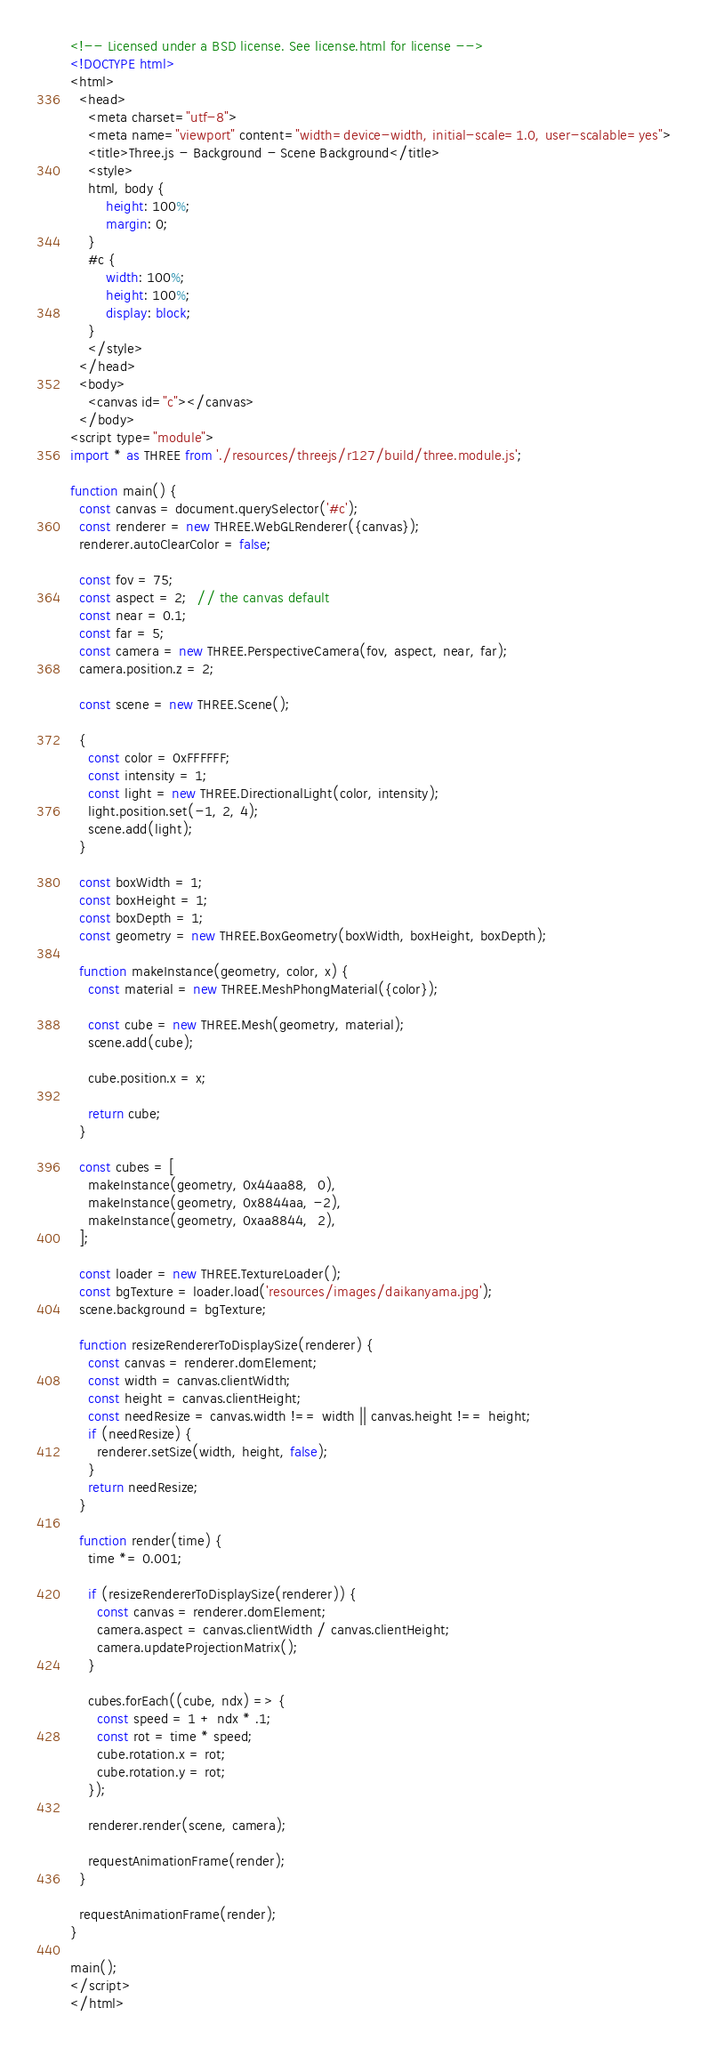<code> <loc_0><loc_0><loc_500><loc_500><_HTML_><!-- Licensed under a BSD license. See license.html for license -->
<!DOCTYPE html>
<html>
  <head>
    <meta charset="utf-8">
    <meta name="viewport" content="width=device-width, initial-scale=1.0, user-scalable=yes">
    <title>Three.js - Background - Scene Background</title>
    <style>
    html, body {
        height: 100%;
        margin: 0;
    }
    #c {
        width: 100%;
        height: 100%;
        display: block;
    }
    </style>
  </head>
  <body>
    <canvas id="c"></canvas>
  </body>
<script type="module">
import * as THREE from './resources/threejs/r127/build/three.module.js';

function main() {
  const canvas = document.querySelector('#c');
  const renderer = new THREE.WebGLRenderer({canvas});
  renderer.autoClearColor = false;

  const fov = 75;
  const aspect = 2;  // the canvas default
  const near = 0.1;
  const far = 5;
  const camera = new THREE.PerspectiveCamera(fov, aspect, near, far);
  camera.position.z = 2;

  const scene = new THREE.Scene();

  {
    const color = 0xFFFFFF;
    const intensity = 1;
    const light = new THREE.DirectionalLight(color, intensity);
    light.position.set(-1, 2, 4);
    scene.add(light);
  }

  const boxWidth = 1;
  const boxHeight = 1;
  const boxDepth = 1;
  const geometry = new THREE.BoxGeometry(boxWidth, boxHeight, boxDepth);

  function makeInstance(geometry, color, x) {
    const material = new THREE.MeshPhongMaterial({color});

    const cube = new THREE.Mesh(geometry, material);
    scene.add(cube);

    cube.position.x = x;

    return cube;
  }

  const cubes = [
    makeInstance(geometry, 0x44aa88,  0),
    makeInstance(geometry, 0x8844aa, -2),
    makeInstance(geometry, 0xaa8844,  2),
  ];

  const loader = new THREE.TextureLoader();
  const bgTexture = loader.load('resources/images/daikanyama.jpg');
  scene.background = bgTexture;

  function resizeRendererToDisplaySize(renderer) {
    const canvas = renderer.domElement;
    const width = canvas.clientWidth;
    const height = canvas.clientHeight;
    const needResize = canvas.width !== width || canvas.height !== height;
    if (needResize) {
      renderer.setSize(width, height, false);
    }
    return needResize;
  }

  function render(time) {
    time *= 0.001;

    if (resizeRendererToDisplaySize(renderer)) {
      const canvas = renderer.domElement;
      camera.aspect = canvas.clientWidth / canvas.clientHeight;
      camera.updateProjectionMatrix();
    }

    cubes.forEach((cube, ndx) => {
      const speed = 1 + ndx * .1;
      const rot = time * speed;
      cube.rotation.x = rot;
      cube.rotation.y = rot;
    });

    renderer.render(scene, camera);

    requestAnimationFrame(render);
  }

  requestAnimationFrame(render);
}

main();
</script>
</html>

</code> 